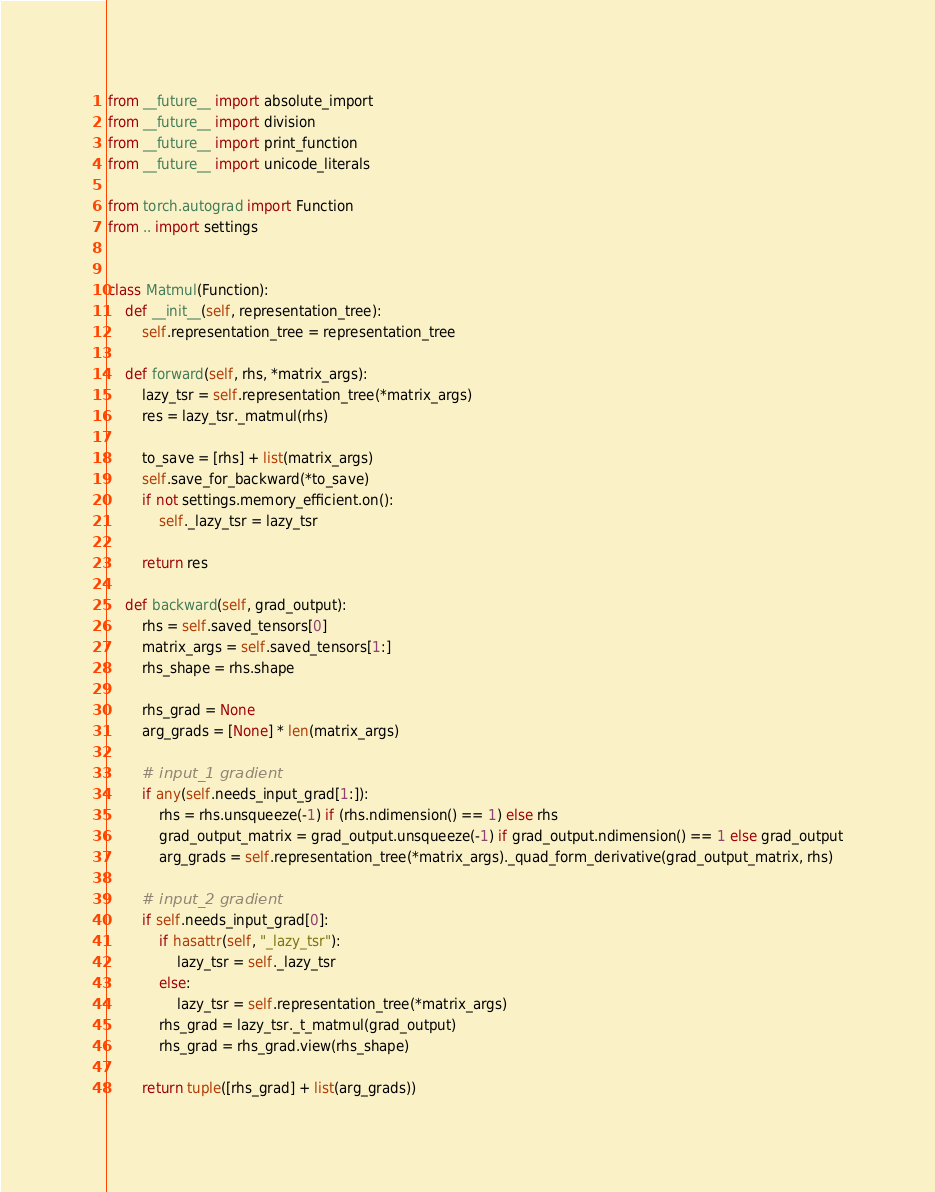<code> <loc_0><loc_0><loc_500><loc_500><_Python_>from __future__ import absolute_import
from __future__ import division
from __future__ import print_function
from __future__ import unicode_literals

from torch.autograd import Function
from .. import settings


class Matmul(Function):
    def __init__(self, representation_tree):
        self.representation_tree = representation_tree

    def forward(self, rhs, *matrix_args):
        lazy_tsr = self.representation_tree(*matrix_args)
        res = lazy_tsr._matmul(rhs)

        to_save = [rhs] + list(matrix_args)
        self.save_for_backward(*to_save)
        if not settings.memory_efficient.on():
            self._lazy_tsr = lazy_tsr

        return res

    def backward(self, grad_output):
        rhs = self.saved_tensors[0]
        matrix_args = self.saved_tensors[1:]
        rhs_shape = rhs.shape

        rhs_grad = None
        arg_grads = [None] * len(matrix_args)

        # input_1 gradient
        if any(self.needs_input_grad[1:]):
            rhs = rhs.unsqueeze(-1) if (rhs.ndimension() == 1) else rhs
            grad_output_matrix = grad_output.unsqueeze(-1) if grad_output.ndimension() == 1 else grad_output
            arg_grads = self.representation_tree(*matrix_args)._quad_form_derivative(grad_output_matrix, rhs)

        # input_2 gradient
        if self.needs_input_grad[0]:
            if hasattr(self, "_lazy_tsr"):
                lazy_tsr = self._lazy_tsr
            else:
                lazy_tsr = self.representation_tree(*matrix_args)
            rhs_grad = lazy_tsr._t_matmul(grad_output)
            rhs_grad = rhs_grad.view(rhs_shape)

        return tuple([rhs_grad] + list(arg_grads))
</code> 